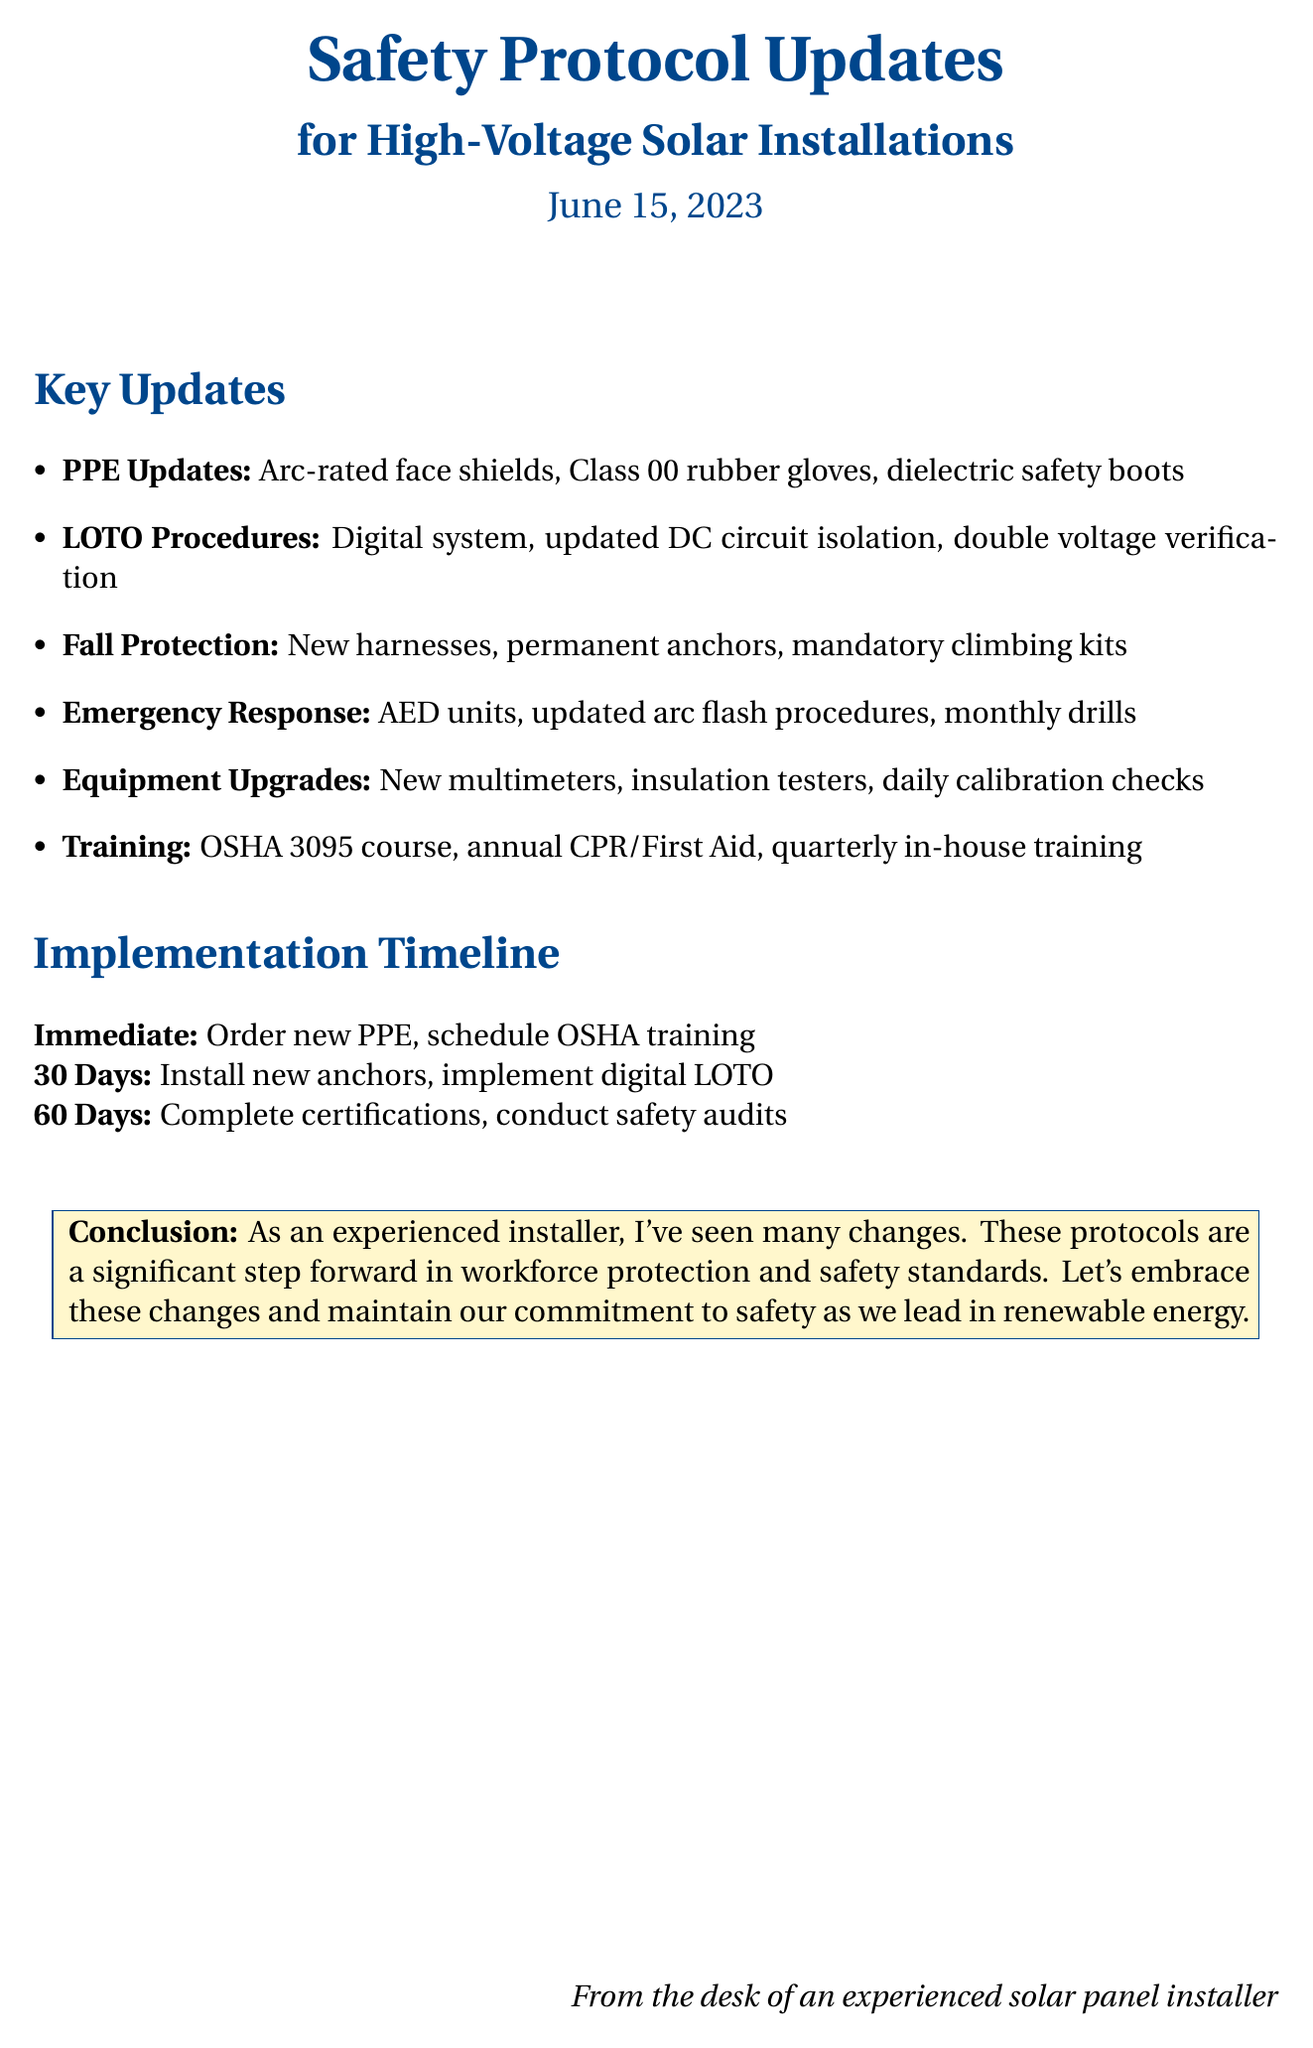What is the date of the memo? The date of the memo is explicitly mentioned at the beginning, which is June 15, 2023.
Answer: June 15, 2023 What is the new requirement for PPE? The new requirement for PPE is specified in the key updates section, which includes arc-rated face shields with a minimum rating of 12 cal/cm².
Answer: Arc-rated face shields with a minimum rating of 12 cal/cm² What digital tool is being implemented for LOTO procedures? The document states that Brady Link360 software will be used for the digital LOTO system.
Answer: Brady Link360 software What is the timeframe for completing all required certifications? The timeline details indicate that all required certifications and training programs should be completed within 60 days.
Answer: 60 days What type of harness is being transitioned to for fall protection? The memo specifies the transition to the Guardian Fall Protection Seraph Construction Harness for improved comfort.
Answer: Guardian Fall Protection Seraph Construction Harness What new safety equipment is mandated for emergency response? The memo lists the integration of AED Plus defibrillator units at all job sites as a new safety equipment requirement.
Answer: AED Plus defibrillator units Which training course is mandatory for all technicians? The document states that all technicians must complete the OSHA 3095 Electrical Safety course.
Answer: OSHA 3095 Electrical Safety course What was a recent incident mentioned in the document? The key points section highlights a March 2023 arc flash injury at a SunPower installation in Arizona as a recent incident.
Answer: Arc flash injury at SunPower installation in Arizona What is one of the immediate actions for implementation? The immediate actions outline that ordering new PPE equipment from Grainger Industrial Supply is required.
Answer: Order new PPE equipment from Grainger Industrial Supply 